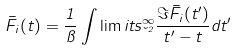Convert formula to latex. <formula><loc_0><loc_0><loc_500><loc_500>\bar { F } _ { i } ( t ) = \frac { 1 } { \pi } \int \lim i t s _ { \lambda ^ { 2 } } ^ { \infty } \frac { \Im \bar { F } _ { i } ( t ^ { \prime } ) } { t ^ { \prime } - t } d t ^ { \prime }</formula> 